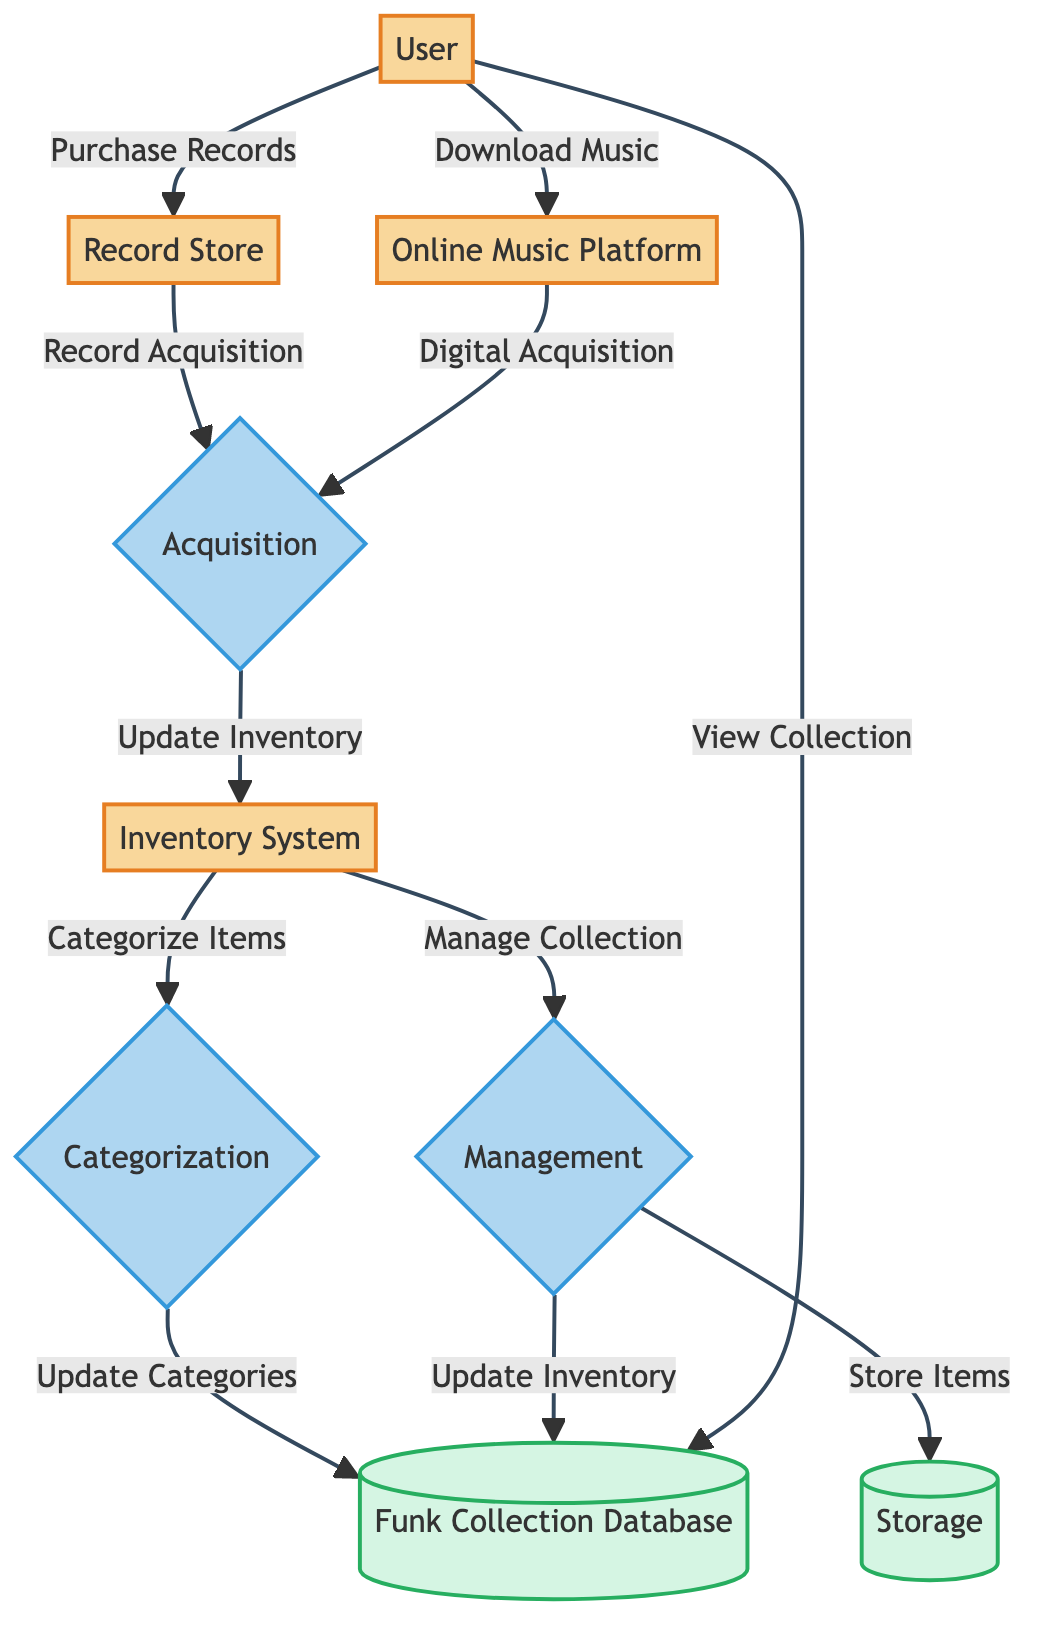What are the main entities in the diagram? The diagram contains four main entities: User, Record Store, Online Music Platform, and Inventory System. These entities represent the actors involved in the inventory management of a personal music collection.
Answer: User, Record Store, Online Music Platform, Inventory System How many processes are depicted in the diagram? The diagram features three main processes: Acquisition, Categorization, and Management. These processes illustrate how records and downloads are handled within the inventory system.
Answer: 3 What is the output of the Acquisition process? The Acquisition process takes inputs from both the Record Store and Online Music Platform and results in an output directed to the Inventory System. Thus, the output of this process is the Inventory System.
Answer: Inventory System Which entity does the User interact with to purchase vinyl records? The User interacts directly with the Record Store to purchase vinyl records, as indicated by the arrow labeled "Purchase Records" in the diagram.
Answer: Record Store What do items categorized in the Inventory System get transferred to? Items that have been categorized in the Inventory System are transferred to the Funk Collection Database as indicated by the output flow labeled "Categorize Items."
Answer: Funk Collection Database How does the Inventory System manage the collection? The Inventory System manages the collection through the Management process, which outputs information both to Storage for physical items and to the Funk Collection Database for inventory updates.
Answer: Storage, Funk Collection Database Which process is responsible for organizing records and downloads into categories? The Categorization process is specifically responsible for organizing records and downloads into categories, receiving information from the Inventory System as its input.
Answer: Categorization What does the User do with the Funk Collection Database? The User interacts with the Funk Collection Database to view detailed information about the collection, as indicated by the flow labeled "View Collection."
Answer: View Collection 